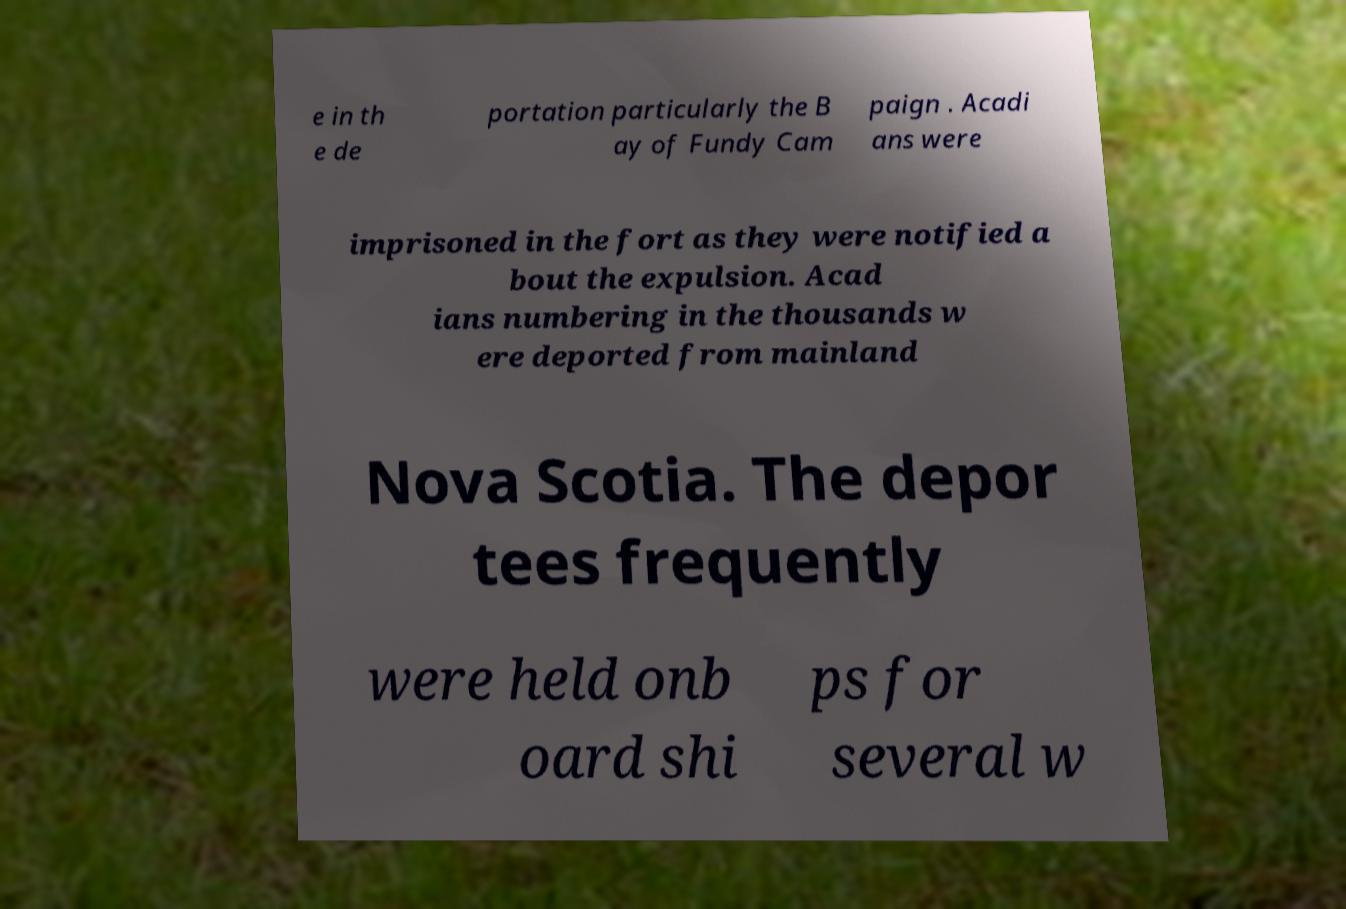There's text embedded in this image that I need extracted. Can you transcribe it verbatim? e in th e de portation particularly the B ay of Fundy Cam paign . Acadi ans were imprisoned in the fort as they were notified a bout the expulsion. Acad ians numbering in the thousands w ere deported from mainland Nova Scotia. The depor tees frequently were held onb oard shi ps for several w 